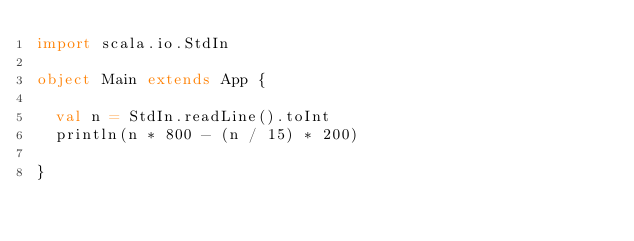Convert code to text. <code><loc_0><loc_0><loc_500><loc_500><_Scala_>import scala.io.StdIn

object Main extends App {

  val n = StdIn.readLine().toInt
  println(n * 800 - (n / 15) * 200)
  
}</code> 